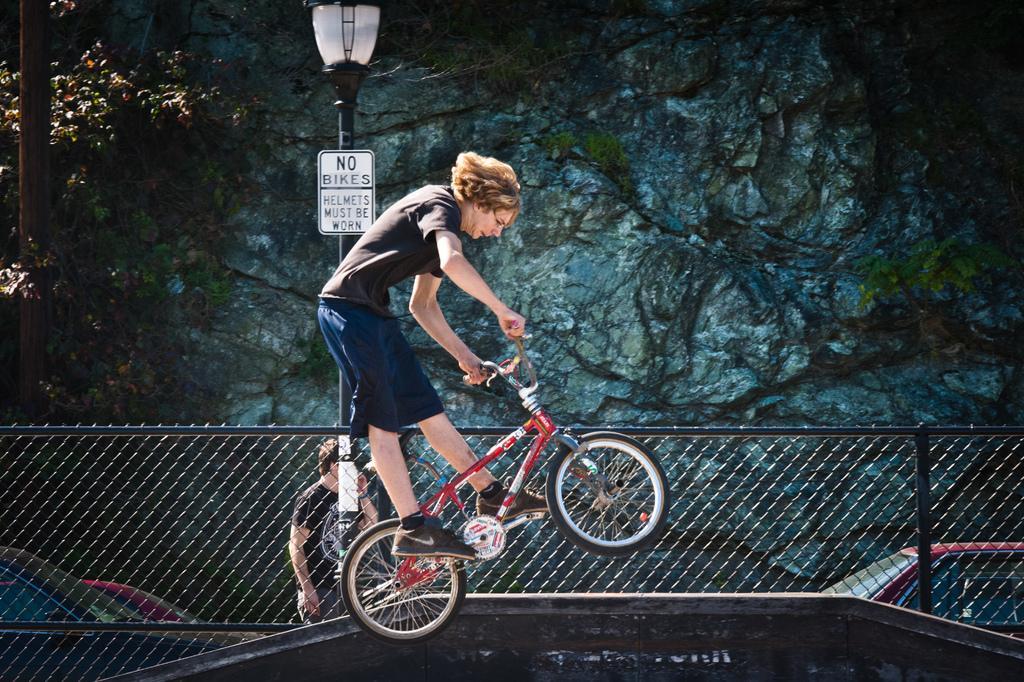How would you summarize this image in a sentence or two? In the image we can see there is a man who is standing on bicycle and at the back there is a street lamp pole. 